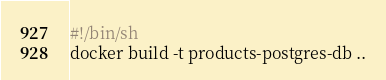<code> <loc_0><loc_0><loc_500><loc_500><_Bash_>#!/bin/sh
docker build -t products-postgres-db ..

</code> 